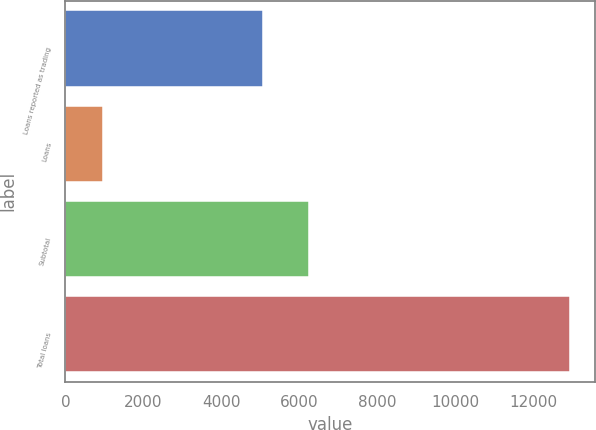Convert chart to OTSL. <chart><loc_0><loc_0><loc_500><loc_500><bar_chart><fcel>Loans reported as trading<fcel>Loans<fcel>Subtotal<fcel>Total loans<nl><fcel>5057<fcel>975<fcel>6252.8<fcel>12933<nl></chart> 